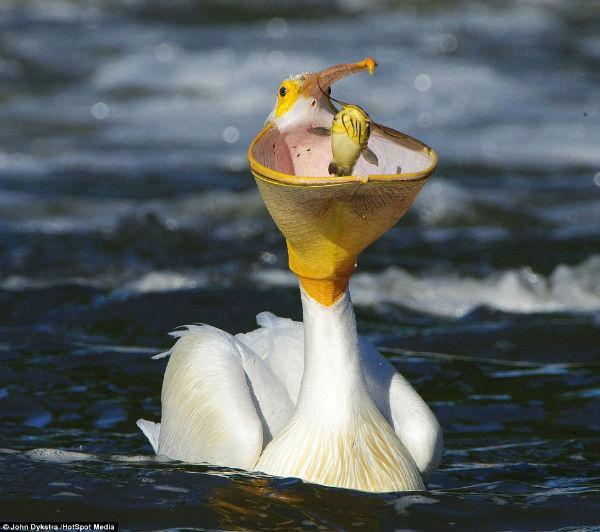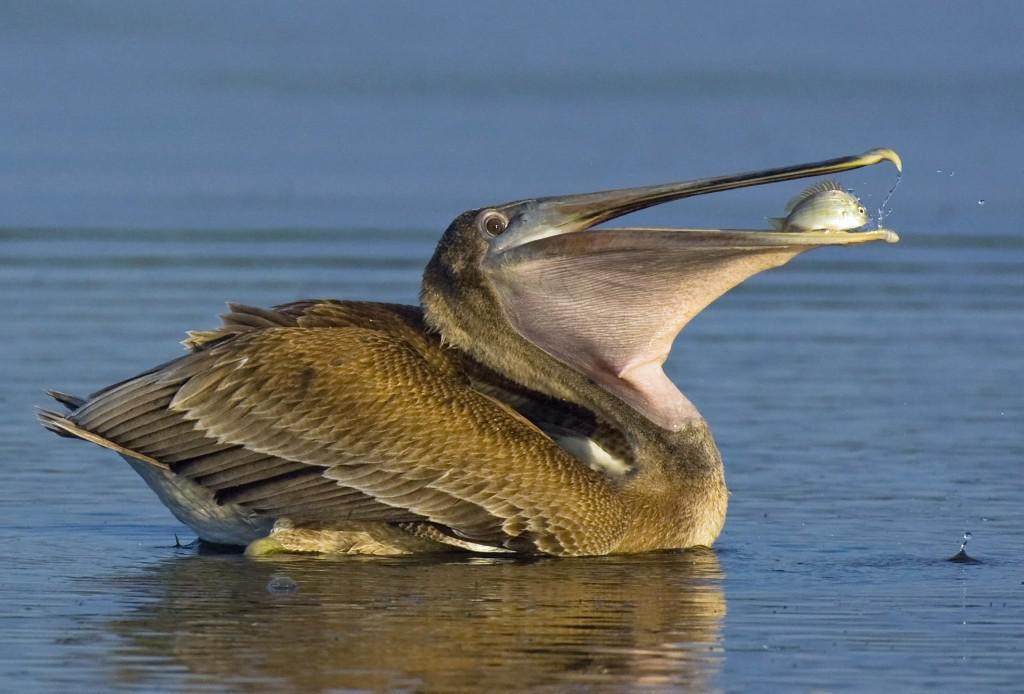The first image is the image on the left, the second image is the image on the right. Examine the images to the left and right. Is the description "At least two fishes are in a bird's mouth." accurate? Answer yes or no. Yes. The first image is the image on the left, the second image is the image on the right. For the images shown, is this caption "Right image shows a dark gray bird with a sac-like expanded lower bill." true? Answer yes or no. Yes. 